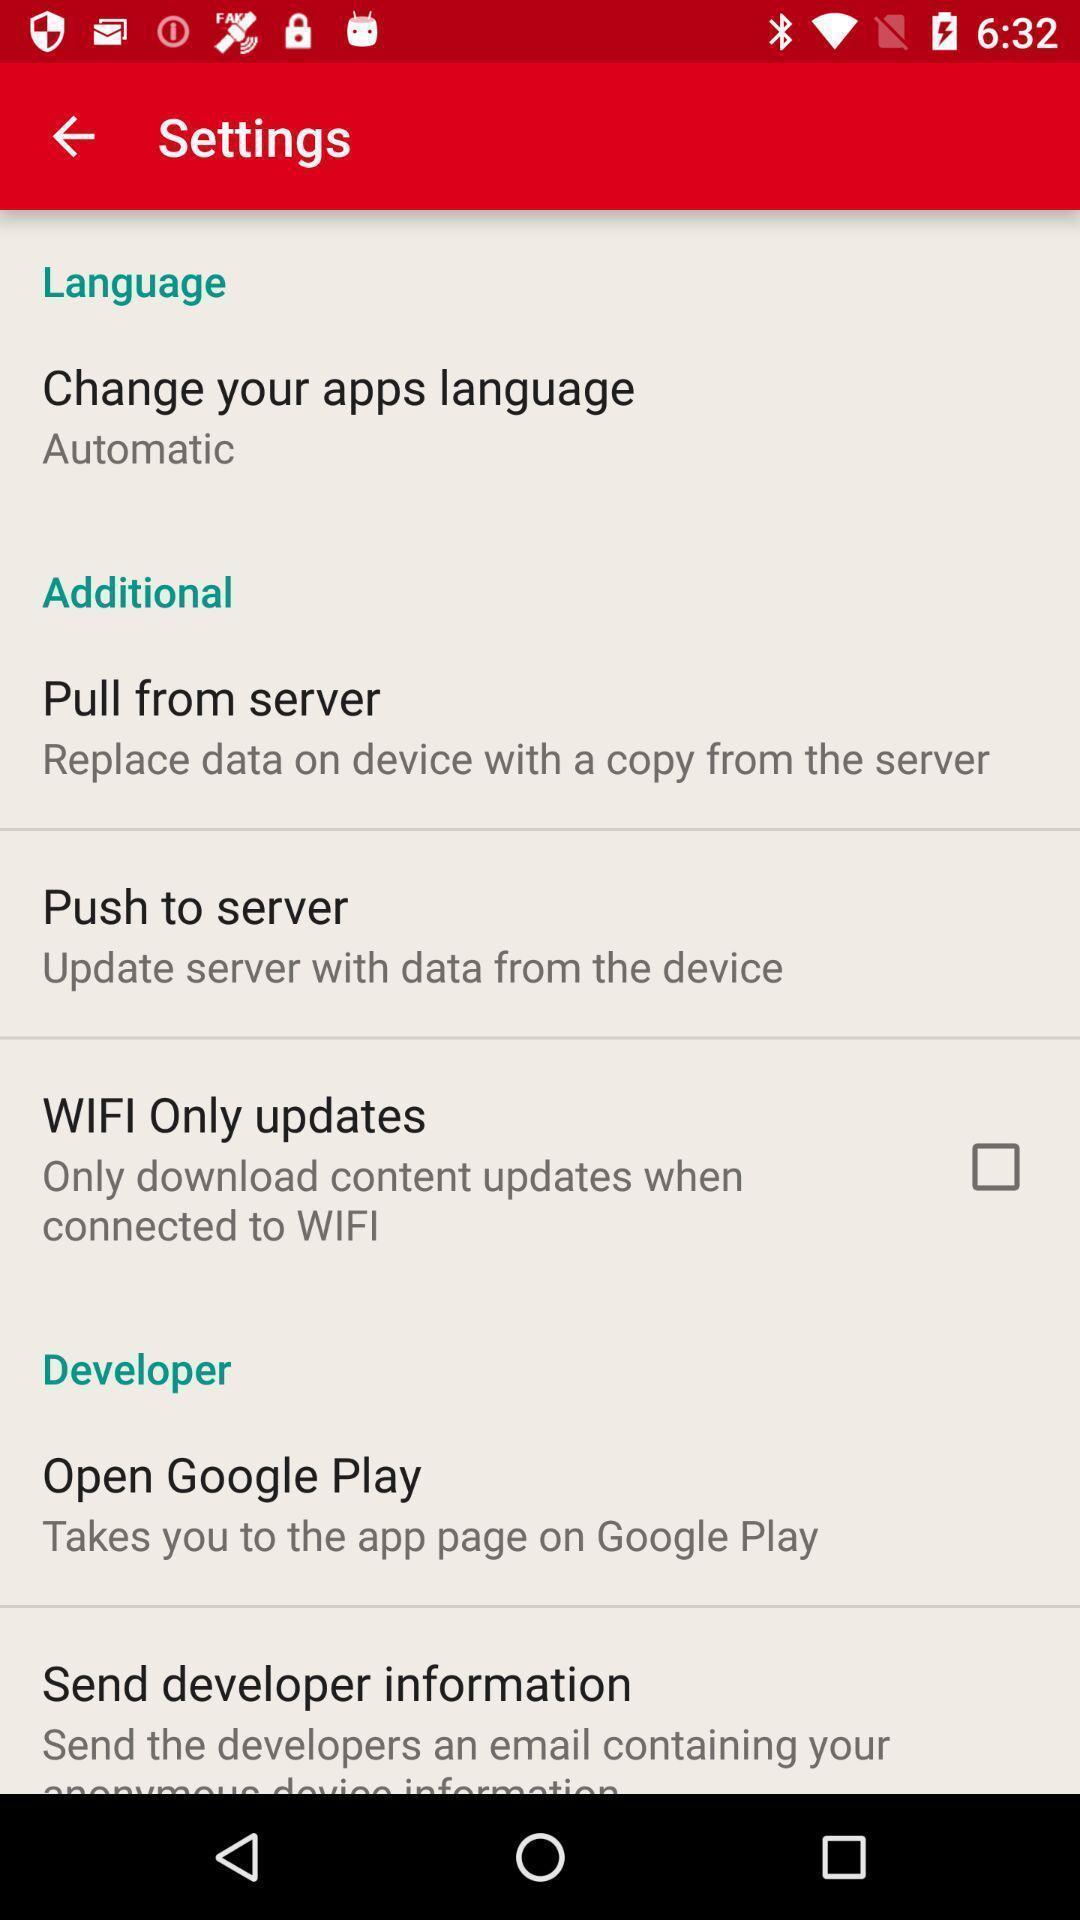What is the overall content of this screenshot? Screen showing settings page. 